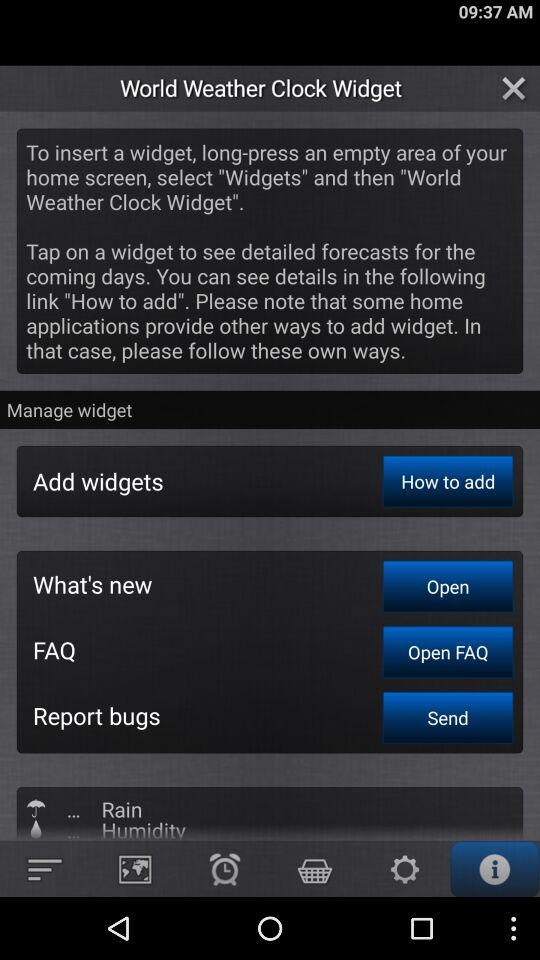Which tab am I on? You are on the "Information" tab. 